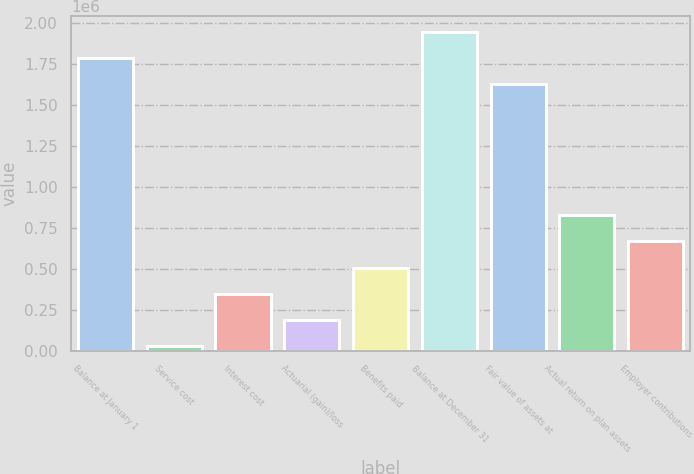Convert chart. <chart><loc_0><loc_0><loc_500><loc_500><bar_chart><fcel>Balance at January 1<fcel>Service cost<fcel>Interest cost<fcel>Actuarial (gain)/loss<fcel>Benefits paid<fcel>Balance at December 31<fcel>Fair value of assets at<fcel>Actual return on plan assets<fcel>Employer contributions<nl><fcel>1.78384e+06<fcel>28194<fcel>347402<fcel>187798<fcel>507006<fcel>1.94344e+06<fcel>1.62423e+06<fcel>826214<fcel>666610<nl></chart> 